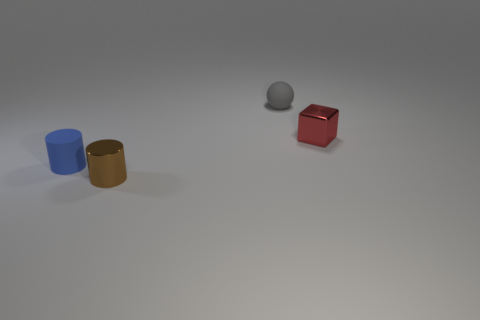Add 3 blue things. How many objects exist? 7 Subtract 1 spheres. How many spheres are left? 0 Subtract all spheres. How many objects are left? 3 Subtract all blue cylinders. How many cylinders are left? 1 Subtract 1 red cubes. How many objects are left? 3 Subtract all green cubes. Subtract all green cylinders. How many cubes are left? 1 Subtract all small cylinders. Subtract all small brown metallic cylinders. How many objects are left? 1 Add 1 gray rubber spheres. How many gray rubber spheres are left? 2 Add 1 tiny yellow rubber objects. How many tiny yellow rubber objects exist? 1 